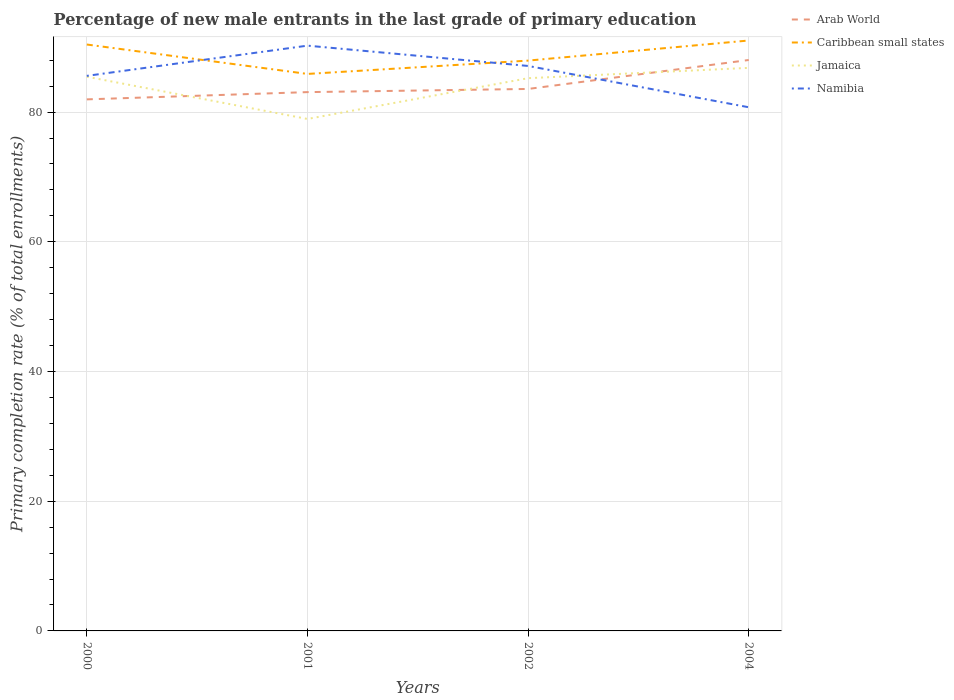How many different coloured lines are there?
Provide a short and direct response. 4. Does the line corresponding to Jamaica intersect with the line corresponding to Namibia?
Offer a very short reply. Yes. Is the number of lines equal to the number of legend labels?
Provide a succinct answer. Yes. Across all years, what is the maximum percentage of new male entrants in Jamaica?
Offer a terse response. 78.94. In which year was the percentage of new male entrants in Arab World maximum?
Offer a very short reply. 2000. What is the total percentage of new male entrants in Namibia in the graph?
Provide a short and direct response. 4.84. What is the difference between the highest and the second highest percentage of new male entrants in Arab World?
Your answer should be compact. 6.07. What is the difference between the highest and the lowest percentage of new male entrants in Arab World?
Ensure brevity in your answer.  1. Is the percentage of new male entrants in Caribbean small states strictly greater than the percentage of new male entrants in Jamaica over the years?
Offer a very short reply. No. How many lines are there?
Give a very brief answer. 4. Are the values on the major ticks of Y-axis written in scientific E-notation?
Your answer should be very brief. No. Does the graph contain grids?
Give a very brief answer. Yes. Where does the legend appear in the graph?
Offer a very short reply. Top right. How are the legend labels stacked?
Your response must be concise. Vertical. What is the title of the graph?
Give a very brief answer. Percentage of new male entrants in the last grade of primary education. Does "Grenada" appear as one of the legend labels in the graph?
Make the answer very short. No. What is the label or title of the Y-axis?
Provide a succinct answer. Primary completion rate (% of total enrollments). What is the Primary completion rate (% of total enrollments) of Arab World in 2000?
Your response must be concise. 81.96. What is the Primary completion rate (% of total enrollments) of Caribbean small states in 2000?
Offer a terse response. 90.42. What is the Primary completion rate (% of total enrollments) in Jamaica in 2000?
Give a very brief answer. 85.45. What is the Primary completion rate (% of total enrollments) of Namibia in 2000?
Give a very brief answer. 85.58. What is the Primary completion rate (% of total enrollments) of Arab World in 2001?
Ensure brevity in your answer.  83.08. What is the Primary completion rate (% of total enrollments) of Caribbean small states in 2001?
Keep it short and to the point. 85.88. What is the Primary completion rate (% of total enrollments) in Jamaica in 2001?
Your answer should be very brief. 78.94. What is the Primary completion rate (% of total enrollments) of Namibia in 2001?
Keep it short and to the point. 90.24. What is the Primary completion rate (% of total enrollments) of Arab World in 2002?
Your answer should be very brief. 83.57. What is the Primary completion rate (% of total enrollments) in Caribbean small states in 2002?
Give a very brief answer. 87.94. What is the Primary completion rate (% of total enrollments) in Jamaica in 2002?
Provide a short and direct response. 85.23. What is the Primary completion rate (% of total enrollments) of Namibia in 2002?
Your answer should be compact. 87.11. What is the Primary completion rate (% of total enrollments) of Arab World in 2004?
Offer a terse response. 88.03. What is the Primary completion rate (% of total enrollments) of Caribbean small states in 2004?
Offer a very short reply. 91.04. What is the Primary completion rate (% of total enrollments) of Jamaica in 2004?
Offer a very short reply. 86.82. What is the Primary completion rate (% of total enrollments) in Namibia in 2004?
Your answer should be very brief. 80.74. Across all years, what is the maximum Primary completion rate (% of total enrollments) in Arab World?
Give a very brief answer. 88.03. Across all years, what is the maximum Primary completion rate (% of total enrollments) of Caribbean small states?
Your response must be concise. 91.04. Across all years, what is the maximum Primary completion rate (% of total enrollments) of Jamaica?
Your answer should be compact. 86.82. Across all years, what is the maximum Primary completion rate (% of total enrollments) of Namibia?
Offer a very short reply. 90.24. Across all years, what is the minimum Primary completion rate (% of total enrollments) in Arab World?
Give a very brief answer. 81.96. Across all years, what is the minimum Primary completion rate (% of total enrollments) of Caribbean small states?
Offer a very short reply. 85.88. Across all years, what is the minimum Primary completion rate (% of total enrollments) of Jamaica?
Your answer should be very brief. 78.94. Across all years, what is the minimum Primary completion rate (% of total enrollments) of Namibia?
Offer a very short reply. 80.74. What is the total Primary completion rate (% of total enrollments) of Arab World in the graph?
Ensure brevity in your answer.  336.63. What is the total Primary completion rate (% of total enrollments) of Caribbean small states in the graph?
Your response must be concise. 355.27. What is the total Primary completion rate (% of total enrollments) in Jamaica in the graph?
Keep it short and to the point. 336.43. What is the total Primary completion rate (% of total enrollments) of Namibia in the graph?
Give a very brief answer. 343.68. What is the difference between the Primary completion rate (% of total enrollments) of Arab World in 2000 and that in 2001?
Give a very brief answer. -1.12. What is the difference between the Primary completion rate (% of total enrollments) of Caribbean small states in 2000 and that in 2001?
Your response must be concise. 4.53. What is the difference between the Primary completion rate (% of total enrollments) in Jamaica in 2000 and that in 2001?
Provide a succinct answer. 6.51. What is the difference between the Primary completion rate (% of total enrollments) in Namibia in 2000 and that in 2001?
Your answer should be very brief. -4.66. What is the difference between the Primary completion rate (% of total enrollments) in Arab World in 2000 and that in 2002?
Offer a terse response. -1.61. What is the difference between the Primary completion rate (% of total enrollments) in Caribbean small states in 2000 and that in 2002?
Provide a short and direct response. 2.48. What is the difference between the Primary completion rate (% of total enrollments) in Jamaica in 2000 and that in 2002?
Keep it short and to the point. 0.22. What is the difference between the Primary completion rate (% of total enrollments) of Namibia in 2000 and that in 2002?
Offer a very short reply. -1.53. What is the difference between the Primary completion rate (% of total enrollments) in Arab World in 2000 and that in 2004?
Your response must be concise. -6.07. What is the difference between the Primary completion rate (% of total enrollments) of Caribbean small states in 2000 and that in 2004?
Give a very brief answer. -0.62. What is the difference between the Primary completion rate (% of total enrollments) of Jamaica in 2000 and that in 2004?
Your answer should be compact. -1.36. What is the difference between the Primary completion rate (% of total enrollments) of Namibia in 2000 and that in 2004?
Your answer should be very brief. 4.84. What is the difference between the Primary completion rate (% of total enrollments) in Arab World in 2001 and that in 2002?
Give a very brief answer. -0.49. What is the difference between the Primary completion rate (% of total enrollments) of Caribbean small states in 2001 and that in 2002?
Provide a succinct answer. -2.05. What is the difference between the Primary completion rate (% of total enrollments) of Jamaica in 2001 and that in 2002?
Give a very brief answer. -6.29. What is the difference between the Primary completion rate (% of total enrollments) in Namibia in 2001 and that in 2002?
Your answer should be compact. 3.13. What is the difference between the Primary completion rate (% of total enrollments) in Arab World in 2001 and that in 2004?
Make the answer very short. -4.95. What is the difference between the Primary completion rate (% of total enrollments) in Caribbean small states in 2001 and that in 2004?
Offer a terse response. -5.15. What is the difference between the Primary completion rate (% of total enrollments) in Jamaica in 2001 and that in 2004?
Make the answer very short. -7.88. What is the difference between the Primary completion rate (% of total enrollments) of Namibia in 2001 and that in 2004?
Offer a very short reply. 9.5. What is the difference between the Primary completion rate (% of total enrollments) in Arab World in 2002 and that in 2004?
Ensure brevity in your answer.  -4.46. What is the difference between the Primary completion rate (% of total enrollments) in Caribbean small states in 2002 and that in 2004?
Ensure brevity in your answer.  -3.1. What is the difference between the Primary completion rate (% of total enrollments) of Jamaica in 2002 and that in 2004?
Ensure brevity in your answer.  -1.59. What is the difference between the Primary completion rate (% of total enrollments) in Namibia in 2002 and that in 2004?
Provide a succinct answer. 6.37. What is the difference between the Primary completion rate (% of total enrollments) in Arab World in 2000 and the Primary completion rate (% of total enrollments) in Caribbean small states in 2001?
Give a very brief answer. -3.92. What is the difference between the Primary completion rate (% of total enrollments) in Arab World in 2000 and the Primary completion rate (% of total enrollments) in Jamaica in 2001?
Provide a short and direct response. 3.02. What is the difference between the Primary completion rate (% of total enrollments) of Arab World in 2000 and the Primary completion rate (% of total enrollments) of Namibia in 2001?
Provide a succinct answer. -8.28. What is the difference between the Primary completion rate (% of total enrollments) in Caribbean small states in 2000 and the Primary completion rate (% of total enrollments) in Jamaica in 2001?
Offer a very short reply. 11.48. What is the difference between the Primary completion rate (% of total enrollments) of Caribbean small states in 2000 and the Primary completion rate (% of total enrollments) of Namibia in 2001?
Your answer should be very brief. 0.17. What is the difference between the Primary completion rate (% of total enrollments) of Jamaica in 2000 and the Primary completion rate (% of total enrollments) of Namibia in 2001?
Give a very brief answer. -4.79. What is the difference between the Primary completion rate (% of total enrollments) in Arab World in 2000 and the Primary completion rate (% of total enrollments) in Caribbean small states in 2002?
Ensure brevity in your answer.  -5.98. What is the difference between the Primary completion rate (% of total enrollments) in Arab World in 2000 and the Primary completion rate (% of total enrollments) in Jamaica in 2002?
Ensure brevity in your answer.  -3.27. What is the difference between the Primary completion rate (% of total enrollments) in Arab World in 2000 and the Primary completion rate (% of total enrollments) in Namibia in 2002?
Make the answer very short. -5.15. What is the difference between the Primary completion rate (% of total enrollments) in Caribbean small states in 2000 and the Primary completion rate (% of total enrollments) in Jamaica in 2002?
Offer a terse response. 5.19. What is the difference between the Primary completion rate (% of total enrollments) in Caribbean small states in 2000 and the Primary completion rate (% of total enrollments) in Namibia in 2002?
Make the answer very short. 3.3. What is the difference between the Primary completion rate (% of total enrollments) in Jamaica in 2000 and the Primary completion rate (% of total enrollments) in Namibia in 2002?
Your answer should be very brief. -1.66. What is the difference between the Primary completion rate (% of total enrollments) of Arab World in 2000 and the Primary completion rate (% of total enrollments) of Caribbean small states in 2004?
Your answer should be very brief. -9.08. What is the difference between the Primary completion rate (% of total enrollments) in Arab World in 2000 and the Primary completion rate (% of total enrollments) in Jamaica in 2004?
Make the answer very short. -4.86. What is the difference between the Primary completion rate (% of total enrollments) of Arab World in 2000 and the Primary completion rate (% of total enrollments) of Namibia in 2004?
Provide a short and direct response. 1.22. What is the difference between the Primary completion rate (% of total enrollments) of Caribbean small states in 2000 and the Primary completion rate (% of total enrollments) of Jamaica in 2004?
Offer a terse response. 3.6. What is the difference between the Primary completion rate (% of total enrollments) in Caribbean small states in 2000 and the Primary completion rate (% of total enrollments) in Namibia in 2004?
Provide a succinct answer. 9.67. What is the difference between the Primary completion rate (% of total enrollments) of Jamaica in 2000 and the Primary completion rate (% of total enrollments) of Namibia in 2004?
Provide a short and direct response. 4.71. What is the difference between the Primary completion rate (% of total enrollments) of Arab World in 2001 and the Primary completion rate (% of total enrollments) of Caribbean small states in 2002?
Make the answer very short. -4.86. What is the difference between the Primary completion rate (% of total enrollments) of Arab World in 2001 and the Primary completion rate (% of total enrollments) of Jamaica in 2002?
Your response must be concise. -2.15. What is the difference between the Primary completion rate (% of total enrollments) of Arab World in 2001 and the Primary completion rate (% of total enrollments) of Namibia in 2002?
Offer a terse response. -4.04. What is the difference between the Primary completion rate (% of total enrollments) of Caribbean small states in 2001 and the Primary completion rate (% of total enrollments) of Jamaica in 2002?
Make the answer very short. 0.66. What is the difference between the Primary completion rate (% of total enrollments) of Caribbean small states in 2001 and the Primary completion rate (% of total enrollments) of Namibia in 2002?
Make the answer very short. -1.23. What is the difference between the Primary completion rate (% of total enrollments) in Jamaica in 2001 and the Primary completion rate (% of total enrollments) in Namibia in 2002?
Ensure brevity in your answer.  -8.17. What is the difference between the Primary completion rate (% of total enrollments) in Arab World in 2001 and the Primary completion rate (% of total enrollments) in Caribbean small states in 2004?
Your answer should be very brief. -7.96. What is the difference between the Primary completion rate (% of total enrollments) in Arab World in 2001 and the Primary completion rate (% of total enrollments) in Jamaica in 2004?
Provide a short and direct response. -3.74. What is the difference between the Primary completion rate (% of total enrollments) of Arab World in 2001 and the Primary completion rate (% of total enrollments) of Namibia in 2004?
Your answer should be compact. 2.34. What is the difference between the Primary completion rate (% of total enrollments) of Caribbean small states in 2001 and the Primary completion rate (% of total enrollments) of Jamaica in 2004?
Ensure brevity in your answer.  -0.93. What is the difference between the Primary completion rate (% of total enrollments) in Caribbean small states in 2001 and the Primary completion rate (% of total enrollments) in Namibia in 2004?
Offer a terse response. 5.14. What is the difference between the Primary completion rate (% of total enrollments) in Jamaica in 2001 and the Primary completion rate (% of total enrollments) in Namibia in 2004?
Provide a succinct answer. -1.8. What is the difference between the Primary completion rate (% of total enrollments) of Arab World in 2002 and the Primary completion rate (% of total enrollments) of Caribbean small states in 2004?
Offer a terse response. -7.47. What is the difference between the Primary completion rate (% of total enrollments) in Arab World in 2002 and the Primary completion rate (% of total enrollments) in Jamaica in 2004?
Provide a short and direct response. -3.25. What is the difference between the Primary completion rate (% of total enrollments) of Arab World in 2002 and the Primary completion rate (% of total enrollments) of Namibia in 2004?
Keep it short and to the point. 2.82. What is the difference between the Primary completion rate (% of total enrollments) in Caribbean small states in 2002 and the Primary completion rate (% of total enrollments) in Jamaica in 2004?
Provide a succinct answer. 1.12. What is the difference between the Primary completion rate (% of total enrollments) in Caribbean small states in 2002 and the Primary completion rate (% of total enrollments) in Namibia in 2004?
Provide a succinct answer. 7.19. What is the difference between the Primary completion rate (% of total enrollments) of Jamaica in 2002 and the Primary completion rate (% of total enrollments) of Namibia in 2004?
Ensure brevity in your answer.  4.48. What is the average Primary completion rate (% of total enrollments) in Arab World per year?
Offer a terse response. 84.16. What is the average Primary completion rate (% of total enrollments) in Caribbean small states per year?
Make the answer very short. 88.82. What is the average Primary completion rate (% of total enrollments) of Jamaica per year?
Provide a short and direct response. 84.11. What is the average Primary completion rate (% of total enrollments) of Namibia per year?
Make the answer very short. 85.92. In the year 2000, what is the difference between the Primary completion rate (% of total enrollments) of Arab World and Primary completion rate (% of total enrollments) of Caribbean small states?
Provide a succinct answer. -8.46. In the year 2000, what is the difference between the Primary completion rate (% of total enrollments) in Arab World and Primary completion rate (% of total enrollments) in Jamaica?
Your answer should be very brief. -3.49. In the year 2000, what is the difference between the Primary completion rate (% of total enrollments) of Arab World and Primary completion rate (% of total enrollments) of Namibia?
Your answer should be very brief. -3.62. In the year 2000, what is the difference between the Primary completion rate (% of total enrollments) in Caribbean small states and Primary completion rate (% of total enrollments) in Jamaica?
Ensure brevity in your answer.  4.97. In the year 2000, what is the difference between the Primary completion rate (% of total enrollments) in Caribbean small states and Primary completion rate (% of total enrollments) in Namibia?
Provide a short and direct response. 4.83. In the year 2000, what is the difference between the Primary completion rate (% of total enrollments) of Jamaica and Primary completion rate (% of total enrollments) of Namibia?
Provide a succinct answer. -0.13. In the year 2001, what is the difference between the Primary completion rate (% of total enrollments) of Arab World and Primary completion rate (% of total enrollments) of Caribbean small states?
Keep it short and to the point. -2.8. In the year 2001, what is the difference between the Primary completion rate (% of total enrollments) in Arab World and Primary completion rate (% of total enrollments) in Jamaica?
Offer a terse response. 4.14. In the year 2001, what is the difference between the Primary completion rate (% of total enrollments) in Arab World and Primary completion rate (% of total enrollments) in Namibia?
Provide a succinct answer. -7.16. In the year 2001, what is the difference between the Primary completion rate (% of total enrollments) of Caribbean small states and Primary completion rate (% of total enrollments) of Jamaica?
Keep it short and to the point. 6.94. In the year 2001, what is the difference between the Primary completion rate (% of total enrollments) of Caribbean small states and Primary completion rate (% of total enrollments) of Namibia?
Provide a succinct answer. -4.36. In the year 2001, what is the difference between the Primary completion rate (% of total enrollments) in Jamaica and Primary completion rate (% of total enrollments) in Namibia?
Your answer should be very brief. -11.3. In the year 2002, what is the difference between the Primary completion rate (% of total enrollments) in Arab World and Primary completion rate (% of total enrollments) in Caribbean small states?
Keep it short and to the point. -4.37. In the year 2002, what is the difference between the Primary completion rate (% of total enrollments) of Arab World and Primary completion rate (% of total enrollments) of Jamaica?
Ensure brevity in your answer.  -1.66. In the year 2002, what is the difference between the Primary completion rate (% of total enrollments) of Arab World and Primary completion rate (% of total enrollments) of Namibia?
Your answer should be very brief. -3.55. In the year 2002, what is the difference between the Primary completion rate (% of total enrollments) in Caribbean small states and Primary completion rate (% of total enrollments) in Jamaica?
Offer a terse response. 2.71. In the year 2002, what is the difference between the Primary completion rate (% of total enrollments) of Caribbean small states and Primary completion rate (% of total enrollments) of Namibia?
Your answer should be very brief. 0.82. In the year 2002, what is the difference between the Primary completion rate (% of total enrollments) of Jamaica and Primary completion rate (% of total enrollments) of Namibia?
Make the answer very short. -1.89. In the year 2004, what is the difference between the Primary completion rate (% of total enrollments) in Arab World and Primary completion rate (% of total enrollments) in Caribbean small states?
Keep it short and to the point. -3.01. In the year 2004, what is the difference between the Primary completion rate (% of total enrollments) in Arab World and Primary completion rate (% of total enrollments) in Jamaica?
Offer a terse response. 1.21. In the year 2004, what is the difference between the Primary completion rate (% of total enrollments) in Arab World and Primary completion rate (% of total enrollments) in Namibia?
Ensure brevity in your answer.  7.29. In the year 2004, what is the difference between the Primary completion rate (% of total enrollments) of Caribbean small states and Primary completion rate (% of total enrollments) of Jamaica?
Make the answer very short. 4.22. In the year 2004, what is the difference between the Primary completion rate (% of total enrollments) of Caribbean small states and Primary completion rate (% of total enrollments) of Namibia?
Your answer should be very brief. 10.29. In the year 2004, what is the difference between the Primary completion rate (% of total enrollments) in Jamaica and Primary completion rate (% of total enrollments) in Namibia?
Your response must be concise. 6.07. What is the ratio of the Primary completion rate (% of total enrollments) in Arab World in 2000 to that in 2001?
Your answer should be very brief. 0.99. What is the ratio of the Primary completion rate (% of total enrollments) of Caribbean small states in 2000 to that in 2001?
Keep it short and to the point. 1.05. What is the ratio of the Primary completion rate (% of total enrollments) in Jamaica in 2000 to that in 2001?
Provide a succinct answer. 1.08. What is the ratio of the Primary completion rate (% of total enrollments) of Namibia in 2000 to that in 2001?
Offer a terse response. 0.95. What is the ratio of the Primary completion rate (% of total enrollments) in Arab World in 2000 to that in 2002?
Provide a short and direct response. 0.98. What is the ratio of the Primary completion rate (% of total enrollments) of Caribbean small states in 2000 to that in 2002?
Ensure brevity in your answer.  1.03. What is the ratio of the Primary completion rate (% of total enrollments) of Jamaica in 2000 to that in 2002?
Your answer should be very brief. 1. What is the ratio of the Primary completion rate (% of total enrollments) of Namibia in 2000 to that in 2002?
Ensure brevity in your answer.  0.98. What is the ratio of the Primary completion rate (% of total enrollments) in Caribbean small states in 2000 to that in 2004?
Offer a terse response. 0.99. What is the ratio of the Primary completion rate (% of total enrollments) of Jamaica in 2000 to that in 2004?
Your answer should be compact. 0.98. What is the ratio of the Primary completion rate (% of total enrollments) in Namibia in 2000 to that in 2004?
Provide a succinct answer. 1.06. What is the ratio of the Primary completion rate (% of total enrollments) in Arab World in 2001 to that in 2002?
Offer a very short reply. 0.99. What is the ratio of the Primary completion rate (% of total enrollments) of Caribbean small states in 2001 to that in 2002?
Your response must be concise. 0.98. What is the ratio of the Primary completion rate (% of total enrollments) in Jamaica in 2001 to that in 2002?
Offer a very short reply. 0.93. What is the ratio of the Primary completion rate (% of total enrollments) of Namibia in 2001 to that in 2002?
Offer a terse response. 1.04. What is the ratio of the Primary completion rate (% of total enrollments) in Arab World in 2001 to that in 2004?
Provide a short and direct response. 0.94. What is the ratio of the Primary completion rate (% of total enrollments) of Caribbean small states in 2001 to that in 2004?
Provide a short and direct response. 0.94. What is the ratio of the Primary completion rate (% of total enrollments) of Jamaica in 2001 to that in 2004?
Give a very brief answer. 0.91. What is the ratio of the Primary completion rate (% of total enrollments) in Namibia in 2001 to that in 2004?
Your answer should be very brief. 1.12. What is the ratio of the Primary completion rate (% of total enrollments) in Arab World in 2002 to that in 2004?
Offer a terse response. 0.95. What is the ratio of the Primary completion rate (% of total enrollments) in Jamaica in 2002 to that in 2004?
Keep it short and to the point. 0.98. What is the ratio of the Primary completion rate (% of total enrollments) of Namibia in 2002 to that in 2004?
Your answer should be compact. 1.08. What is the difference between the highest and the second highest Primary completion rate (% of total enrollments) of Arab World?
Your answer should be very brief. 4.46. What is the difference between the highest and the second highest Primary completion rate (% of total enrollments) in Caribbean small states?
Give a very brief answer. 0.62. What is the difference between the highest and the second highest Primary completion rate (% of total enrollments) of Jamaica?
Provide a short and direct response. 1.36. What is the difference between the highest and the second highest Primary completion rate (% of total enrollments) in Namibia?
Offer a very short reply. 3.13. What is the difference between the highest and the lowest Primary completion rate (% of total enrollments) of Arab World?
Your answer should be compact. 6.07. What is the difference between the highest and the lowest Primary completion rate (% of total enrollments) in Caribbean small states?
Offer a very short reply. 5.15. What is the difference between the highest and the lowest Primary completion rate (% of total enrollments) of Jamaica?
Provide a succinct answer. 7.88. What is the difference between the highest and the lowest Primary completion rate (% of total enrollments) of Namibia?
Give a very brief answer. 9.5. 